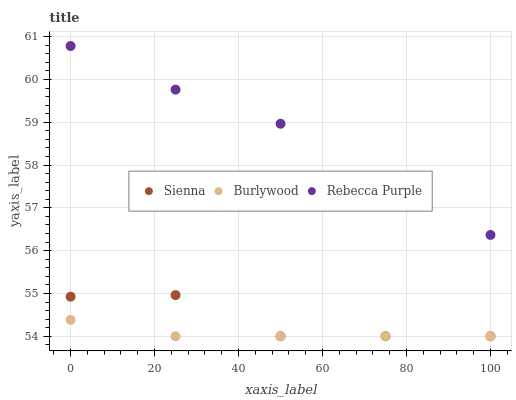Does Burlywood have the minimum area under the curve?
Answer yes or no. Yes. Does Rebecca Purple have the maximum area under the curve?
Answer yes or no. Yes. Does Rebecca Purple have the minimum area under the curve?
Answer yes or no. No. Does Burlywood have the maximum area under the curve?
Answer yes or no. No. Is Burlywood the smoothest?
Answer yes or no. Yes. Is Sienna the roughest?
Answer yes or no. Yes. Is Rebecca Purple the smoothest?
Answer yes or no. No. Is Rebecca Purple the roughest?
Answer yes or no. No. Does Sienna have the lowest value?
Answer yes or no. Yes. Does Rebecca Purple have the lowest value?
Answer yes or no. No. Does Rebecca Purple have the highest value?
Answer yes or no. Yes. Does Burlywood have the highest value?
Answer yes or no. No. Is Burlywood less than Rebecca Purple?
Answer yes or no. Yes. Is Rebecca Purple greater than Sienna?
Answer yes or no. Yes. Does Sienna intersect Burlywood?
Answer yes or no. Yes. Is Sienna less than Burlywood?
Answer yes or no. No. Is Sienna greater than Burlywood?
Answer yes or no. No. Does Burlywood intersect Rebecca Purple?
Answer yes or no. No. 